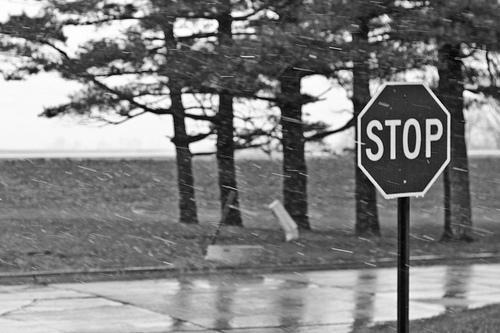How many trees are visible?
Give a very brief answer. 5. How many sides are on the STOP sign?
Give a very brief answer. 8. 